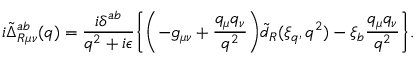Convert formula to latex. <formula><loc_0><loc_0><loc_500><loc_500>i \tilde { \Delta } _ { R \mu \nu } ^ { a b } ( q ) = \frac { i \delta ^ { a b } } { q ^ { 2 } + i \epsilon } \left \{ \left ( - g _ { \mu \nu } + \frac { q _ { \mu } q _ { \nu } } { q ^ { 2 } } \right ) \tilde { d } _ { R } ( \xi _ { q } , q ^ { 2 } ) - \xi _ { b } \frac { q _ { \mu } q _ { \nu } } { q ^ { 2 } } \right \} .</formula> 